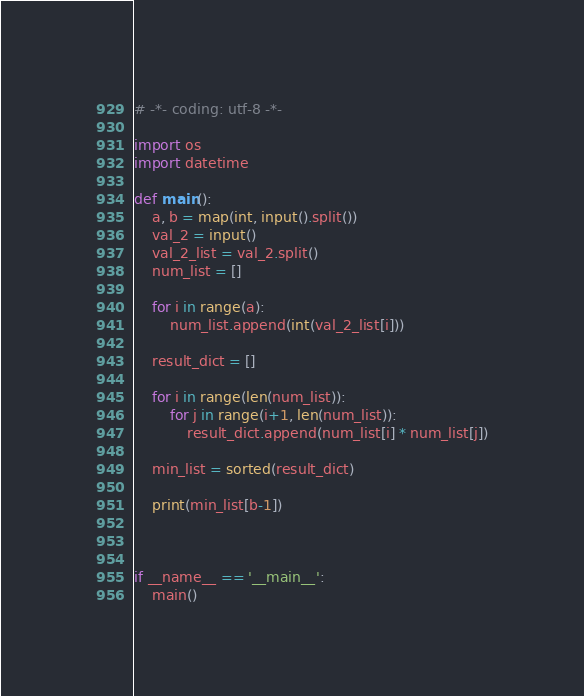<code> <loc_0><loc_0><loc_500><loc_500><_Python_># -*- coding: utf-8 -*-

import os
import datetime

def main():
    a, b = map(int, input().split())
    val_2 = input()
    val_2_list = val_2.split()
    num_list = []

    for i in range(a):
        num_list.append(int(val_2_list[i]))

    result_dict = []

    for i in range(len(num_list)):
        for j in range(i+1, len(num_list)):
            result_dict.append(num_list[i] * num_list[j])

    min_list = sorted(result_dict)

    print(min_list[b-1])



if __name__ == '__main__':
    main()</code> 